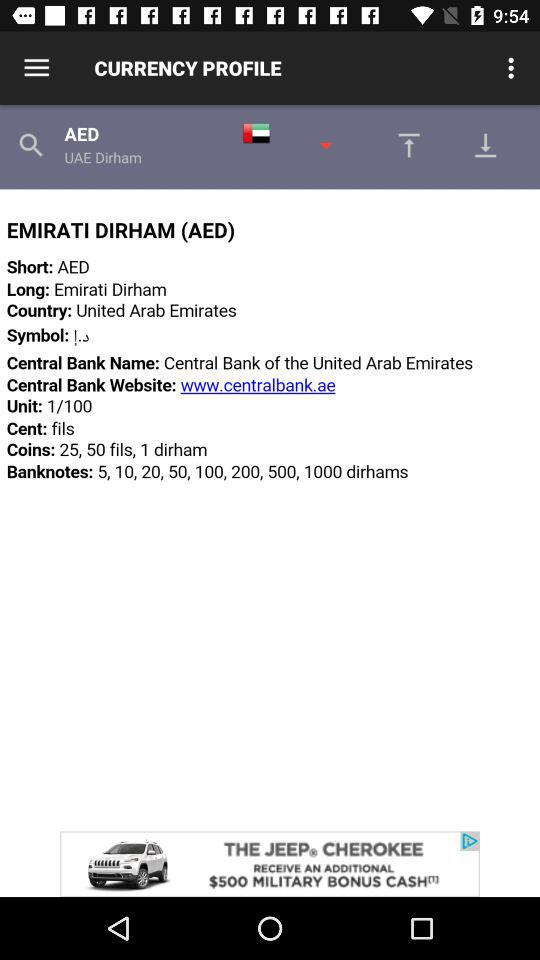What is the country name? The country name is the United Arab Emirates. 